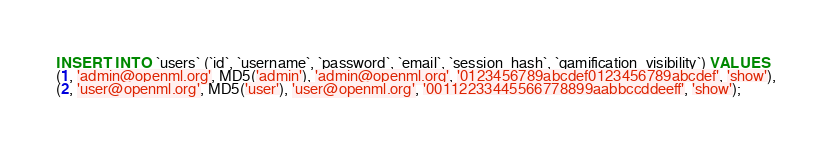<code> <loc_0><loc_0><loc_500><loc_500><_SQL_>INSERT INTO `users` (`id`, `username`, `password`, `email`, `session_hash`, `gamification_visibility`) VALUES
(1, 'admin@openml.org', MD5('admin'), 'admin@openml.org', '0123456789abcdef0123456789abcdef', 'show'),
(2, 'user@openml.org', MD5('user'), 'user@openml.org', '00112233445566778899aabbccddeeff', 'show');
</code> 